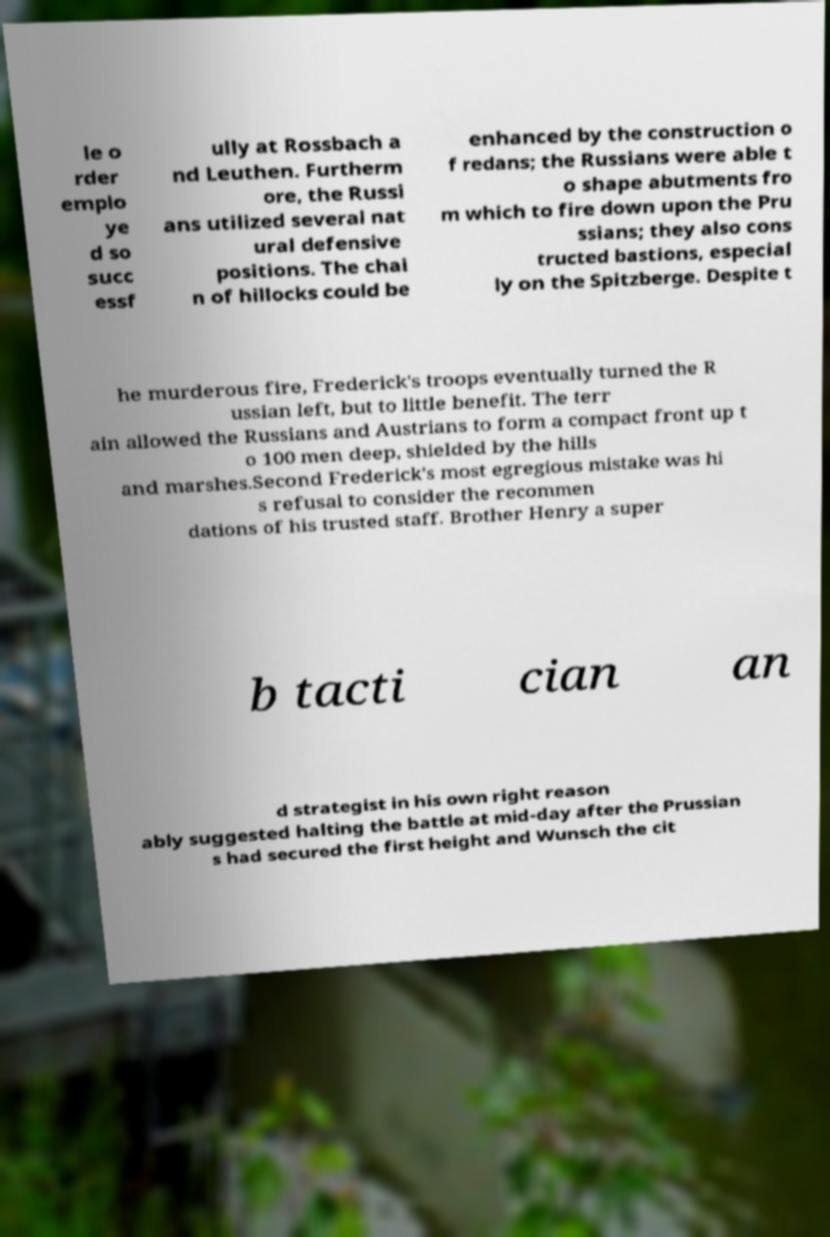Could you assist in decoding the text presented in this image and type it out clearly? le o rder emplo ye d so succ essf ully at Rossbach a nd Leuthen. Furtherm ore, the Russi ans utilized several nat ural defensive positions. The chai n of hillocks could be enhanced by the construction o f redans; the Russians were able t o shape abutments fro m which to fire down upon the Pru ssians; they also cons tructed bastions, especial ly on the Spitzberge. Despite t he murderous fire, Frederick's troops eventually turned the R ussian left, but to little benefit. The terr ain allowed the Russians and Austrians to form a compact front up t o 100 men deep, shielded by the hills and marshes.Second Frederick's most egregious mistake was hi s refusal to consider the recommen dations of his trusted staff. Brother Henry a super b tacti cian an d strategist in his own right reason ably suggested halting the battle at mid-day after the Prussian s had secured the first height and Wunsch the cit 